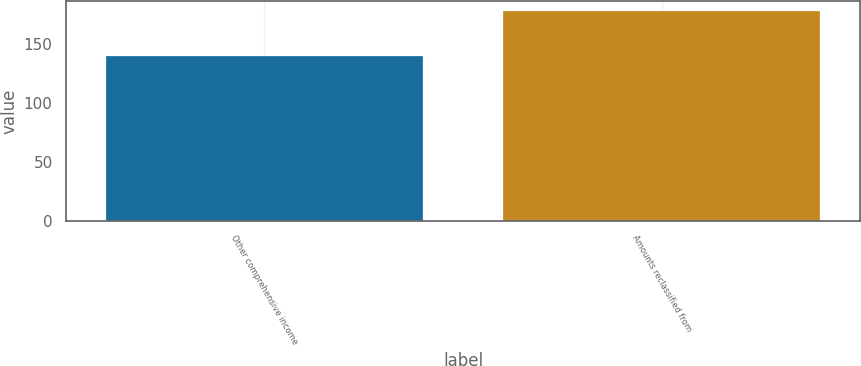Convert chart to OTSL. <chart><loc_0><loc_0><loc_500><loc_500><bar_chart><fcel>Other comprehensive income<fcel>Amounts reclassified from<nl><fcel>140<fcel>178<nl></chart> 